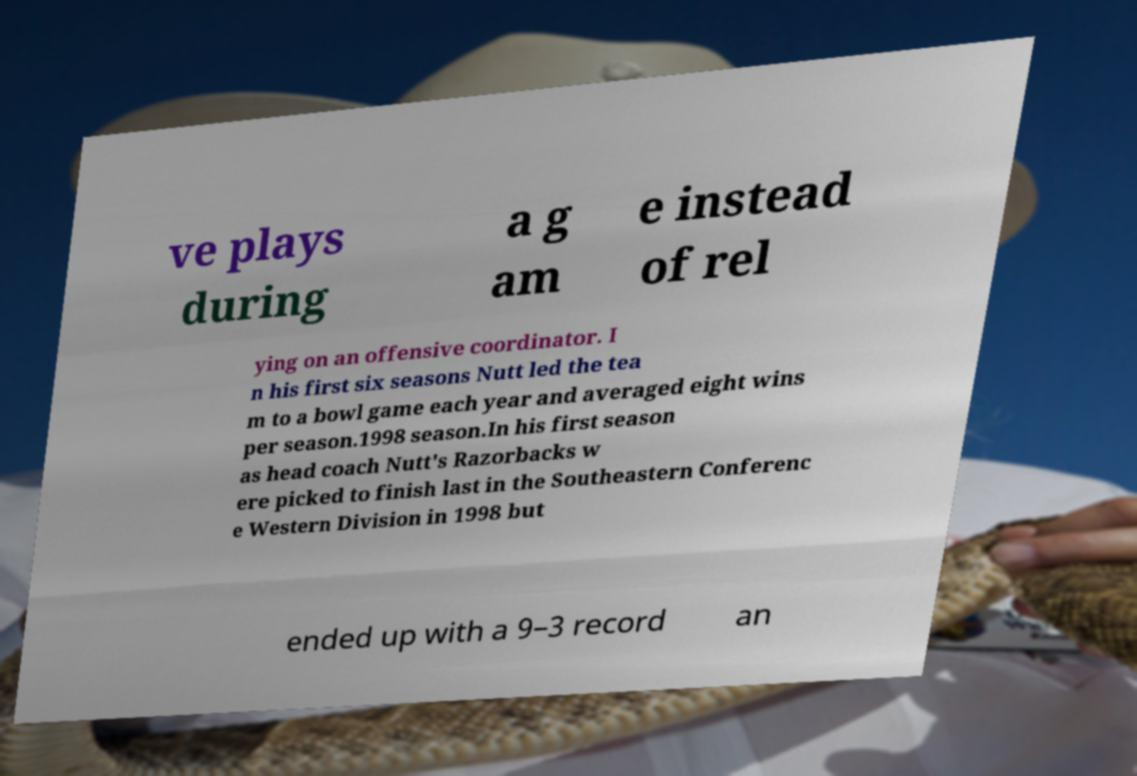Could you assist in decoding the text presented in this image and type it out clearly? ve plays during a g am e instead of rel ying on an offensive coordinator. I n his first six seasons Nutt led the tea m to a bowl game each year and averaged eight wins per season.1998 season.In his first season as head coach Nutt's Razorbacks w ere picked to finish last in the Southeastern Conferenc e Western Division in 1998 but ended up with a 9–3 record an 